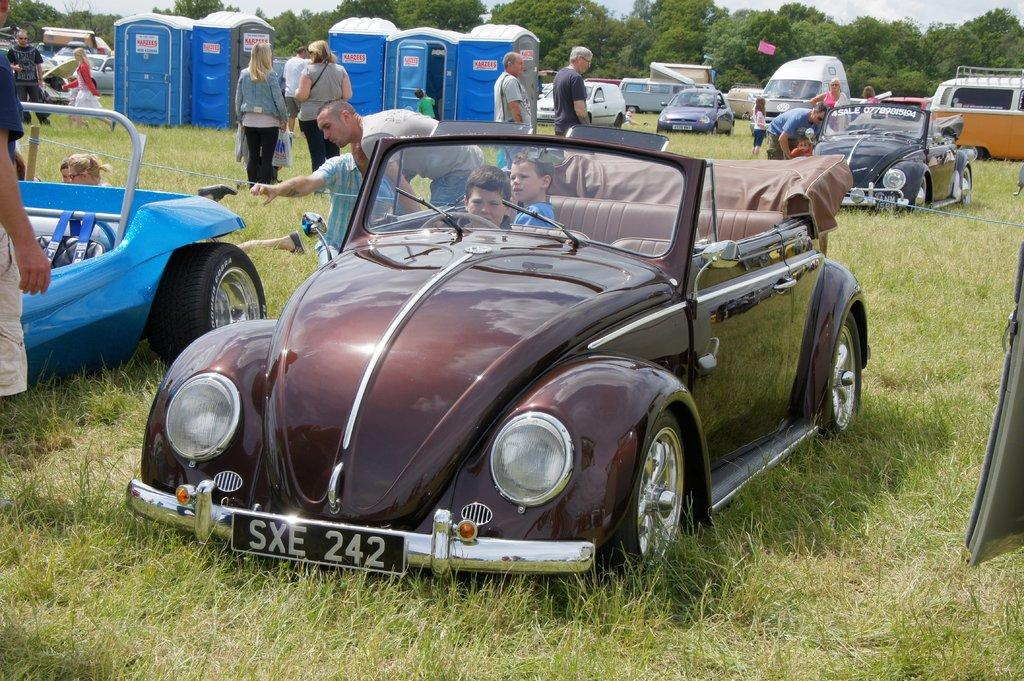What types of objects can be seen in the image? There are vehicles and sheds in the image. Are there any living beings present in the image? Yes, there are people in the image. What is the ground surface like in the image? There is grass at the bottom of the image. What can be seen in the background of the image? There are trees and sky visible in the background of the image. Can you see any ants crawling on the vehicles in the image? There are no ants visible in the image. What type of fang can be seen on the people in the image? There are no fangs present on the people in the image. 